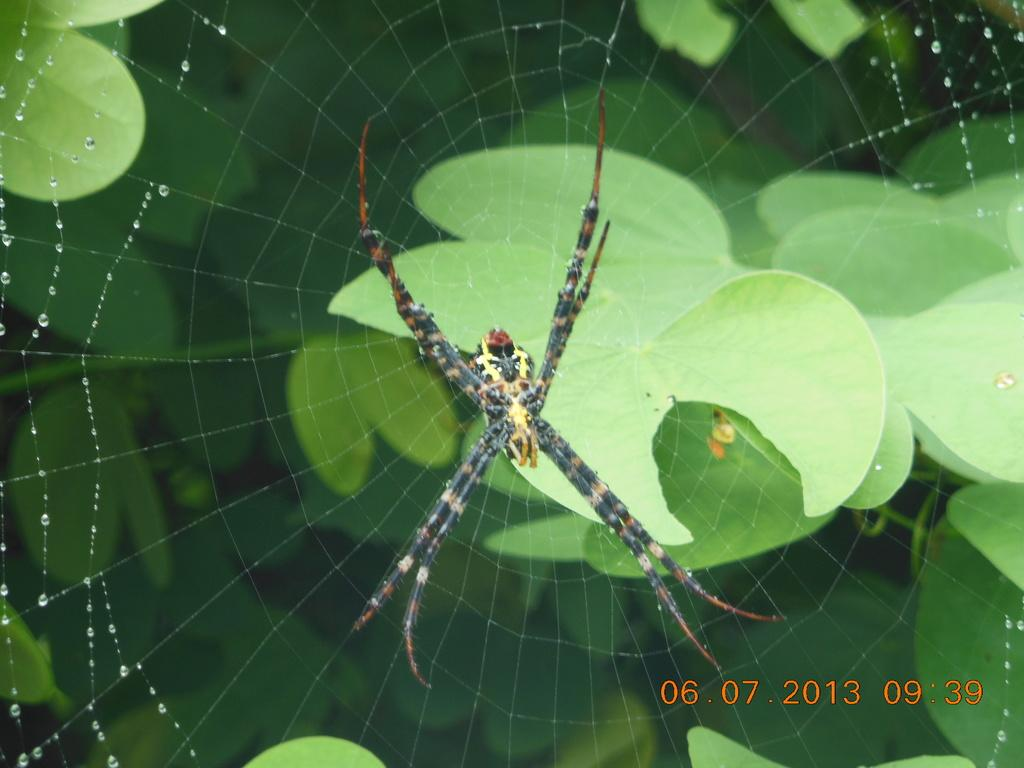What is the main subject of the image? There is a spider in the image. What is the spider associated with? The spider has a web. What is present on the spider's web? There are water drops on the web. What can be seen in the background of the image? There are green leaves in the background of the image. Is there any text or symbol present in the image? Yes, there is a watermark on the right side bottom of the image. What information does the watermark provide? The watermark represents the date and time. What type of knife is the spider holding in the image? There is no knife present in the image. 